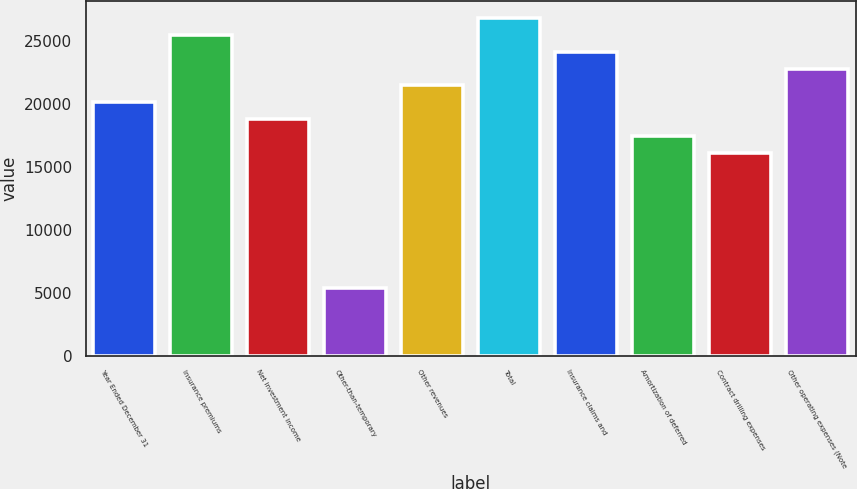Convert chart to OTSL. <chart><loc_0><loc_0><loc_500><loc_500><bar_chart><fcel>Year Ended December 31<fcel>Insurance premiums<fcel>Net investment income<fcel>Other-than-temporary<fcel>Other revenues<fcel>Total<fcel>Insurance claims and<fcel>Amortization of deferred<fcel>Contract drilling expenses<fcel>Other operating expenses (Note<nl><fcel>20122.2<fcel>25487.9<fcel>18780.7<fcel>5366.44<fcel>21463.6<fcel>26829.3<fcel>24146.5<fcel>17439.3<fcel>16097.9<fcel>22805<nl></chart> 